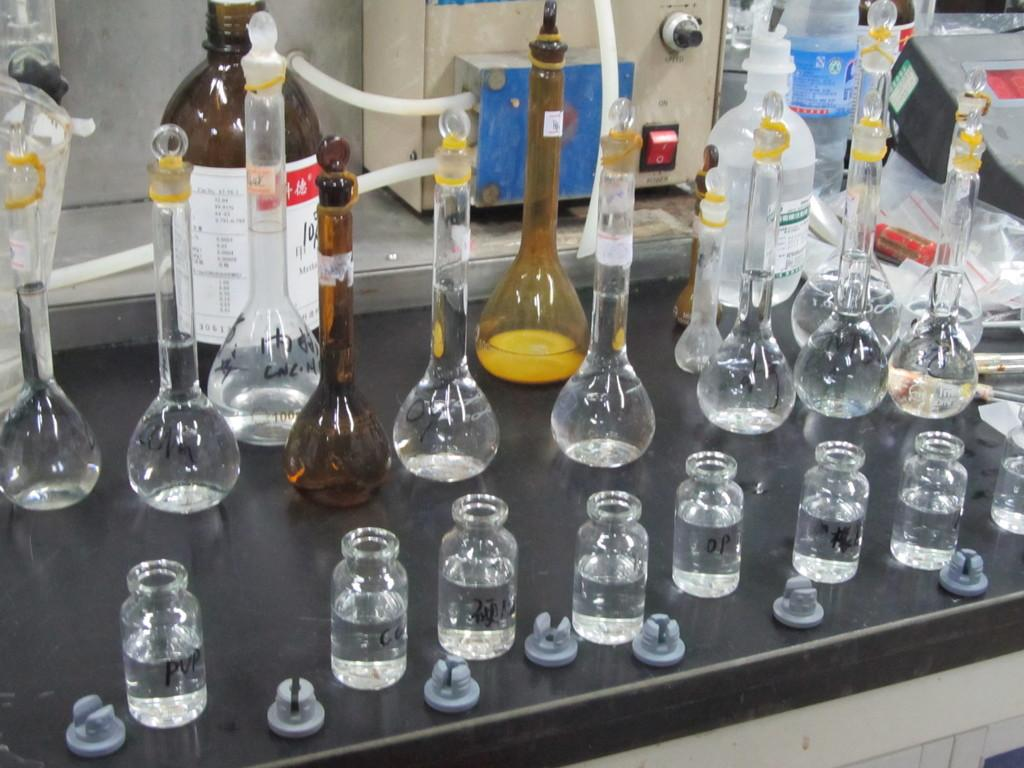What type of location is depicted in the image? The image depicts a chemistry lab. What types of containers are present in the lab? There are bottles, jars, and containers in the lab. Where are these items located in the lab? All of these items are present on a table in the lab. Are there any tin ants crawling on the berries in the image? There are no berries or tin ants present in the image; it depicts a chemistry lab with bottles, jars, and containers on a table. 